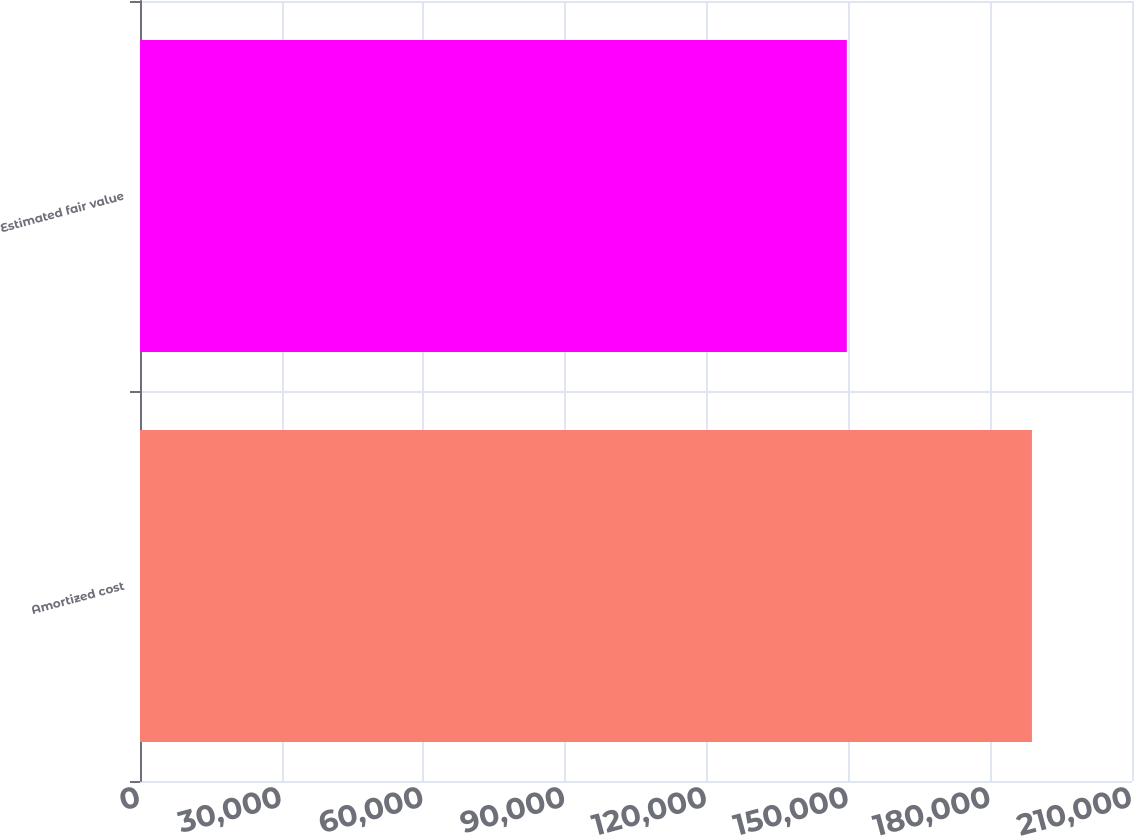Convert chart to OTSL. <chart><loc_0><loc_0><loc_500><loc_500><bar_chart><fcel>Amortized cost<fcel>Estimated fair value<nl><fcel>188819<fcel>149632<nl></chart> 